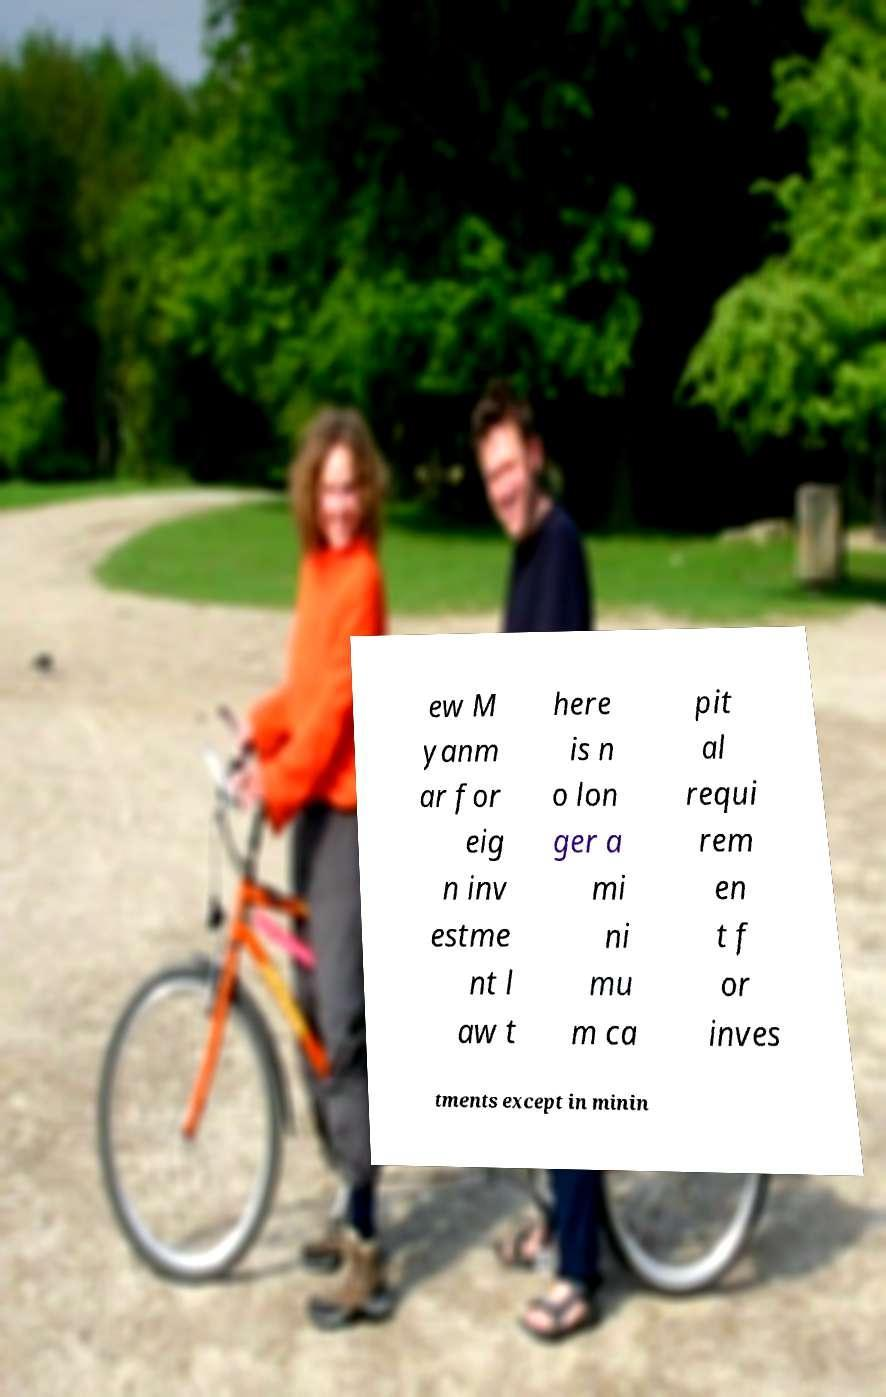I need the written content from this picture converted into text. Can you do that? ew M yanm ar for eig n inv estme nt l aw t here is n o lon ger a mi ni mu m ca pit al requi rem en t f or inves tments except in minin 